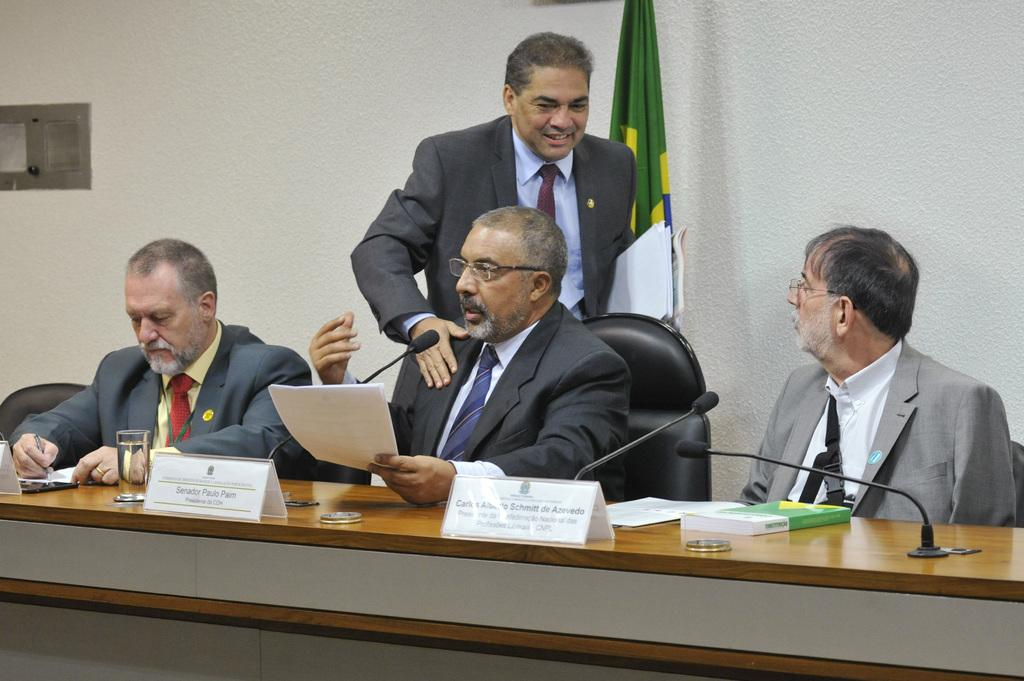How many people are in the image? There are three people in the image. What are the people doing in the image? The people are sitting on chairs in the image. Where are the chairs located in relation to the desk? The chairs are in front of a desk. What can be found on the desk in the image? There are things on the desk, including glasses. Can you describe the man visible behind the people in the image? There is a man visible behind the people in the image. What type of ray is swimming in the water behind the people in the image? There is no water or ray visible in the image; it features people sitting in chairs in front of a desk. 